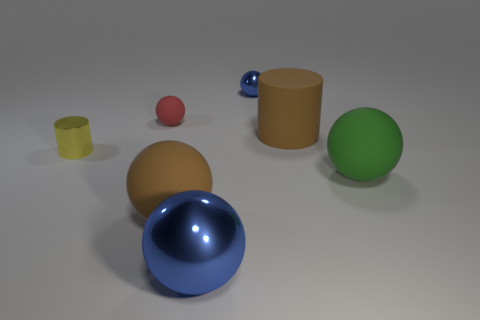How many other objects are the same material as the yellow cylinder?
Your answer should be compact. 2. What is the material of the tiny yellow cylinder?
Your response must be concise. Metal. Do the large object that is left of the big blue shiny object and the cylinder right of the big blue metal object have the same color?
Your answer should be very brief. Yes. Is the number of big green things behind the brown matte ball greater than the number of red rubber cubes?
Ensure brevity in your answer.  Yes. How many other objects are there of the same color as the large metallic thing?
Make the answer very short. 1. There is a metal object that is in front of the brown sphere; is its size the same as the large brown cylinder?
Make the answer very short. Yes. Is there a green thing of the same size as the yellow cylinder?
Offer a very short reply. No. The cylinder that is to the right of the tiny red ball is what color?
Ensure brevity in your answer.  Brown. There is a object that is to the left of the big blue ball and to the right of the red sphere; what shape is it?
Offer a very short reply. Sphere. What number of brown objects have the same shape as the small red rubber thing?
Offer a terse response. 1. 